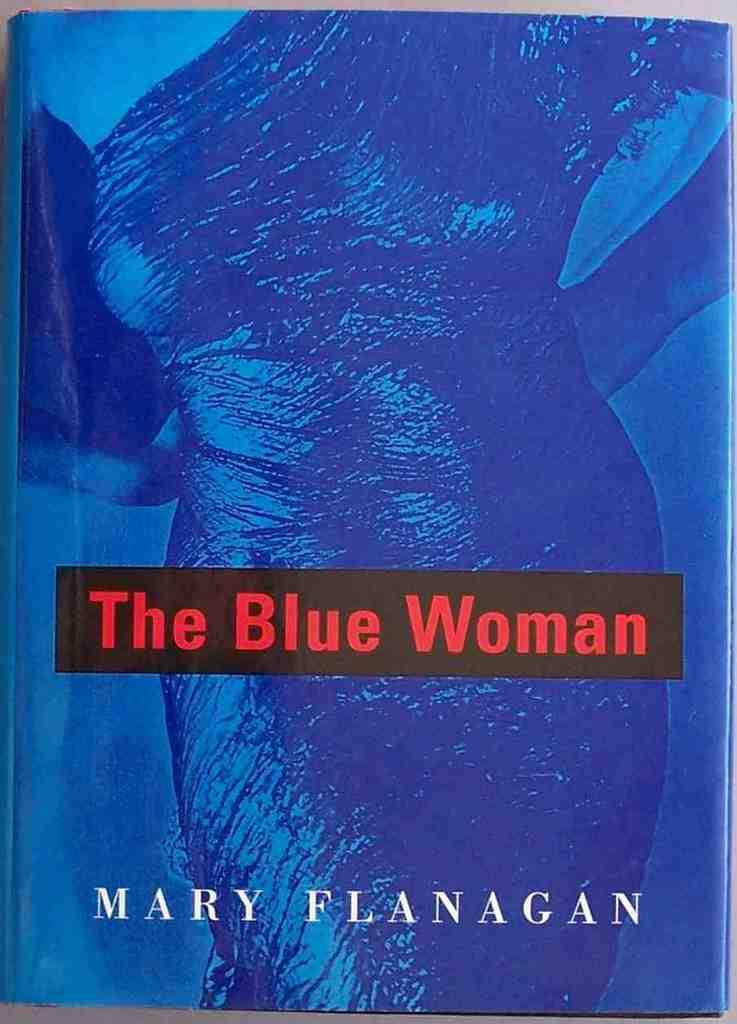<image>
Describe the image concisely. The book cover of The Blue Woman shows a woman wearing a dress. 